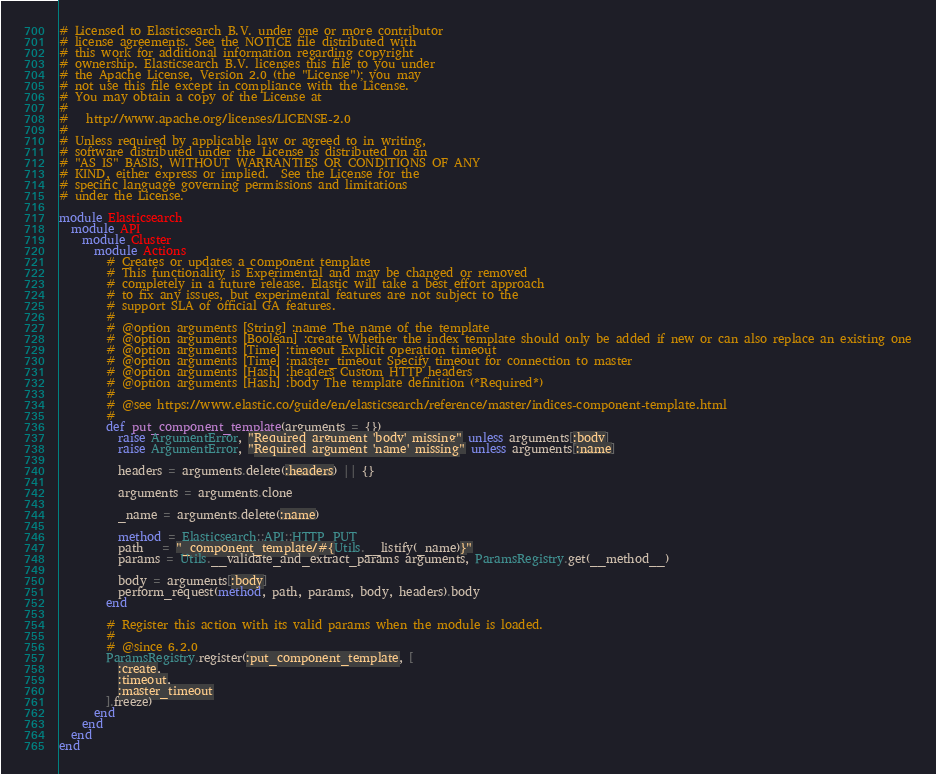Convert code to text. <code><loc_0><loc_0><loc_500><loc_500><_Ruby_># Licensed to Elasticsearch B.V. under one or more contributor
# license agreements. See the NOTICE file distributed with
# this work for additional information regarding copyright
# ownership. Elasticsearch B.V. licenses this file to you under
# the Apache License, Version 2.0 (the "License"); you may
# not use this file except in compliance with the License.
# You may obtain a copy of the License at
#
#   http://www.apache.org/licenses/LICENSE-2.0
#
# Unless required by applicable law or agreed to in writing,
# software distributed under the License is distributed on an
# "AS IS" BASIS, WITHOUT WARRANTIES OR CONDITIONS OF ANY
# KIND, either express or implied.  See the License for the
# specific language governing permissions and limitations
# under the License.

module Elasticsearch
  module API
    module Cluster
      module Actions
        # Creates or updates a component template
        # This functionality is Experimental and may be changed or removed
        # completely in a future release. Elastic will take a best effort approach
        # to fix any issues, but experimental features are not subject to the
        # support SLA of official GA features.
        #
        # @option arguments [String] :name The name of the template
        # @option arguments [Boolean] :create Whether the index template should only be added if new or can also replace an existing one
        # @option arguments [Time] :timeout Explicit operation timeout
        # @option arguments [Time] :master_timeout Specify timeout for connection to master
        # @option arguments [Hash] :headers Custom HTTP headers
        # @option arguments [Hash] :body The template definition (*Required*)
        #
        # @see https://www.elastic.co/guide/en/elasticsearch/reference/master/indices-component-template.html
        #
        def put_component_template(arguments = {})
          raise ArgumentError, "Required argument 'body' missing" unless arguments[:body]
          raise ArgumentError, "Required argument 'name' missing" unless arguments[:name]

          headers = arguments.delete(:headers) || {}

          arguments = arguments.clone

          _name = arguments.delete(:name)

          method = Elasticsearch::API::HTTP_PUT
          path   = "_component_template/#{Utils.__listify(_name)}"
          params = Utils.__validate_and_extract_params arguments, ParamsRegistry.get(__method__)

          body = arguments[:body]
          perform_request(method, path, params, body, headers).body
        end

        # Register this action with its valid params when the module is loaded.
        #
        # @since 6.2.0
        ParamsRegistry.register(:put_component_template, [
          :create,
          :timeout,
          :master_timeout
        ].freeze)
      end
    end
  end
end
</code> 